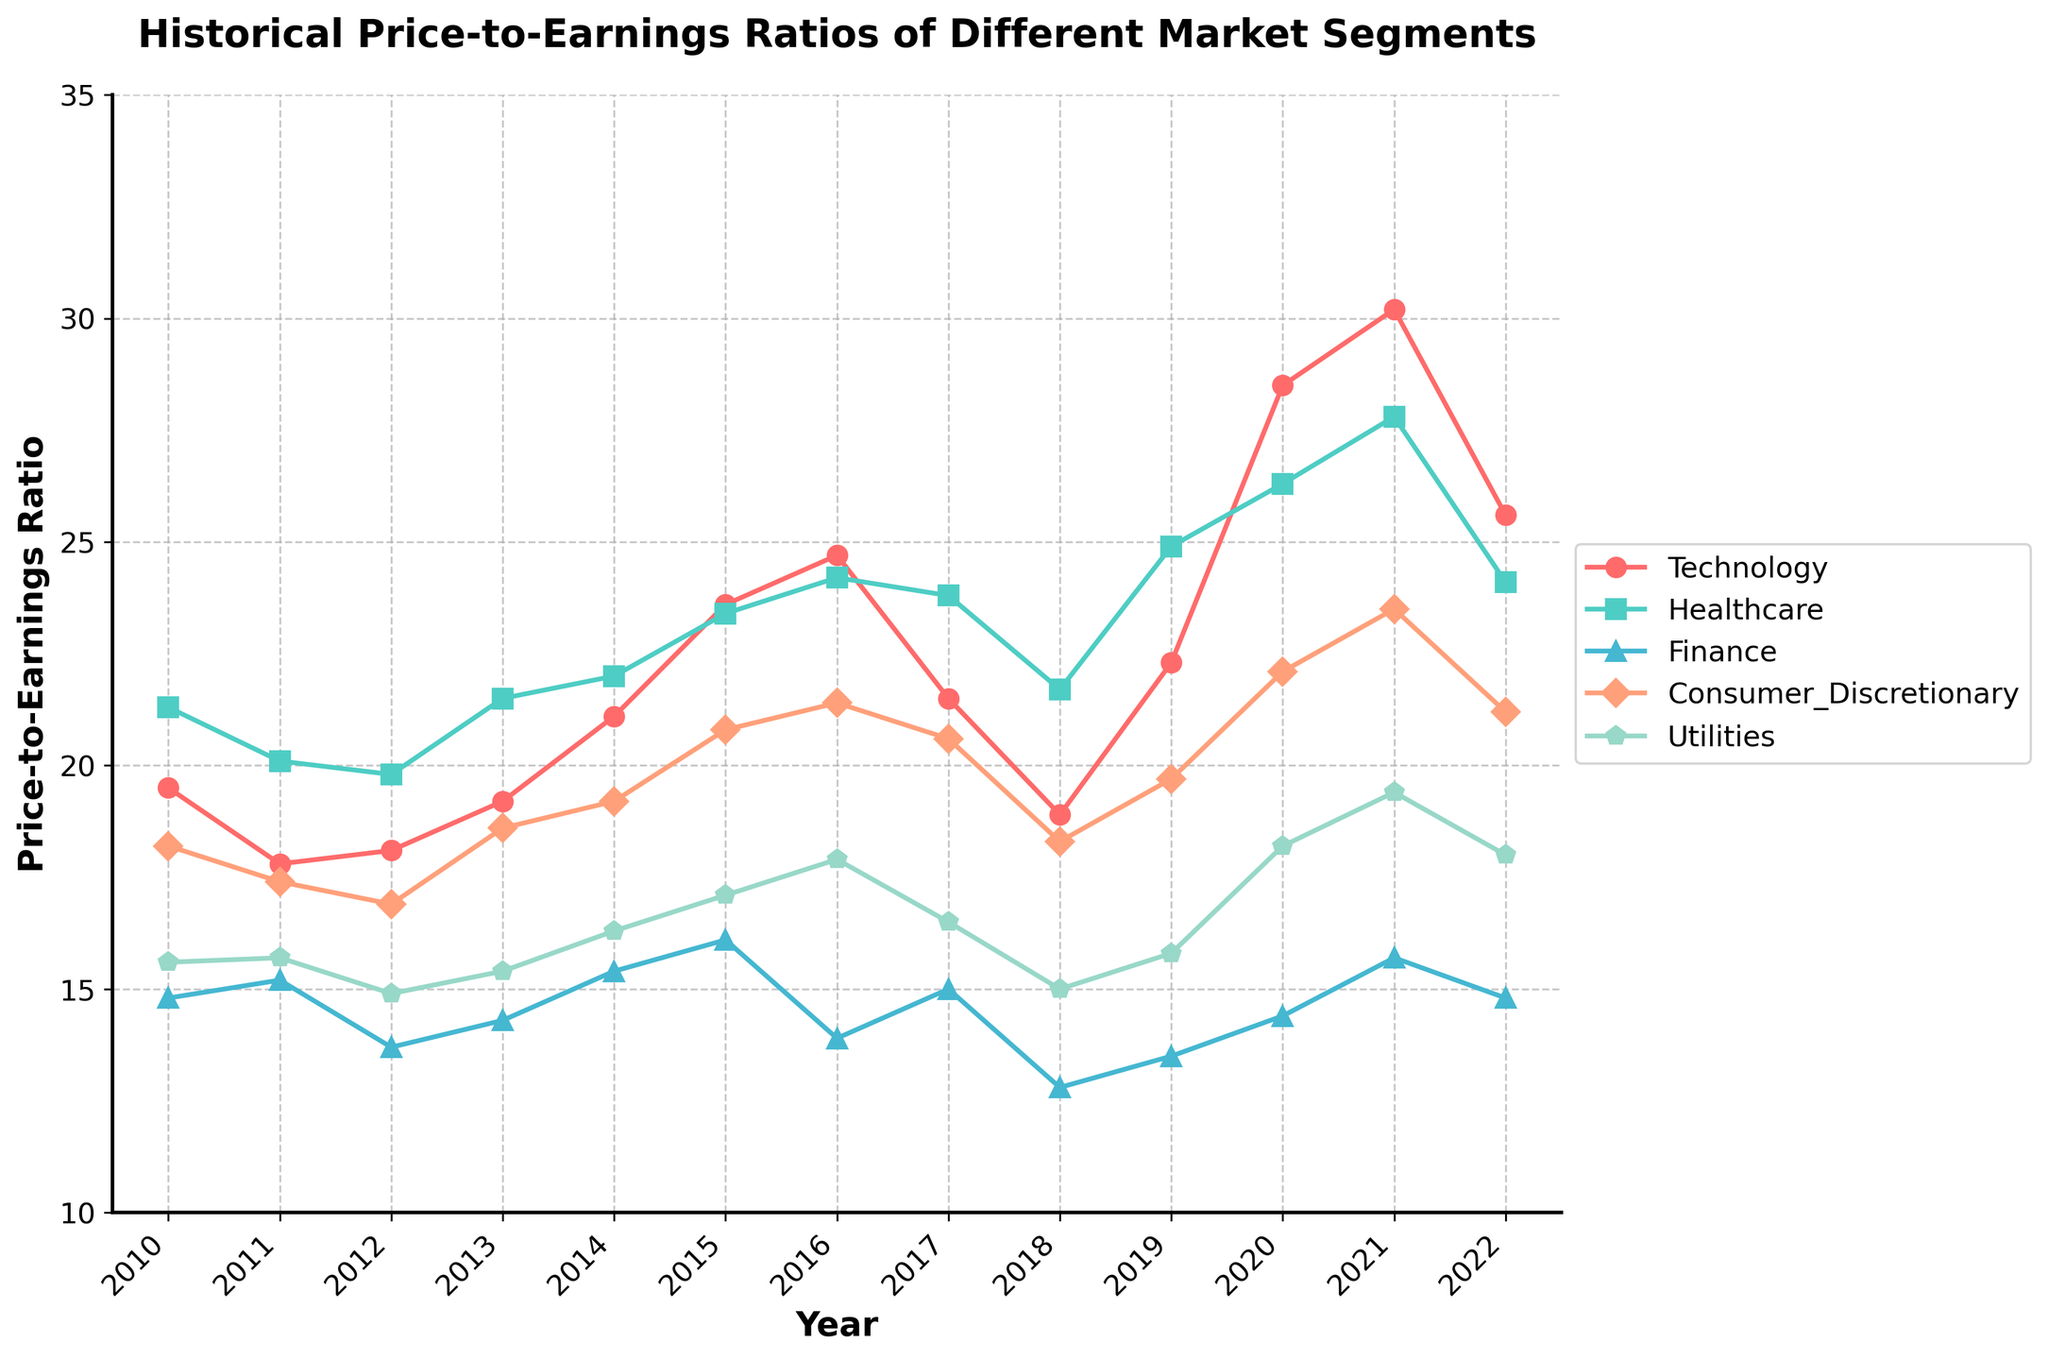what is the title of the figure? The title is usually placed at the top of the figure. Here, it reads "Historical Price-to-Earnings Ratios of Different Market Segments".
Answer: Historical Price-to-Earnings Ratios of Different Market Segments How many market segments are displayed in the plot? By counting the number of labels in the legend on the right side of the plot, you can see there are five segments: Technology, Healthcare, Finance, Consumer Discretionary, and Utilities.
Answer: Five Which market segment showed the highest Price-to-Earnings ratio in 2021? By looking at the 2021 data point for all market segments, the segment with the highest PE is Technology, which is around 30.2.
Answer: Technology How does the Price-to-Earnings ratio of Finance compare between 2010 and 2022? By comparing the PE ratios for Finance at 2010 (14.8) and 2022 (14.8), it is evident that the PE ratio remained the same over these years.
Answer: The same Which market segment has the most stable Price-to-Earnings ratio over the years? To determine stability, check the fluctuations for each segment. Utilities have the smallest range and relatively stable pattern compared to others.
Answer: Utilities In which year did the Technology segment show the highest Price-to-Earnings ratio? By spotting the peaks along the Technology trend line, the highest point is seen in 2021 with a PE ratio of 30.2.
Answer: 2021 What was the average Price-to-Earnings ratio of the Healthcare segment from 2010 to 2015? Calculate the average by summing the PE numbers for Healthcare from 2010 to 2015: (21.3 + 20.1 + 19.8 + 21.5 + 22.0 + 23.4) and dividing by 6, which results in approximately 21.85.
Answer: 21.85 Which year saw the biggest difference in Price-to-Earnings ratio between Technology and Finance segments? Calculate the differences between Technology and Finance PEs for each year and find the greatest disparity: 2021, with Technology at 30.2 and Finance at 15.7, yielding a difference of 14.5.
Answer: 2021 Between 2020 and 2021, which market segment experienced the smallest change in Price-to-Earnings ratio? By calculating the difference between 2020 and 2021 PE ratios for each segment, Utilities had the smallest change (19.4 - 18.2 = 1.2).
Answer: Utilities What is the general trend of the Price-to-Earnings ratio for the Technology segment from 2010 to 2022? Observe the Technology trend line, which starts about 19.5 in 2010, increases to peak around 2021, and drops slightly by 2022. Overall, it shows an upward trend.
Answer: Upward 